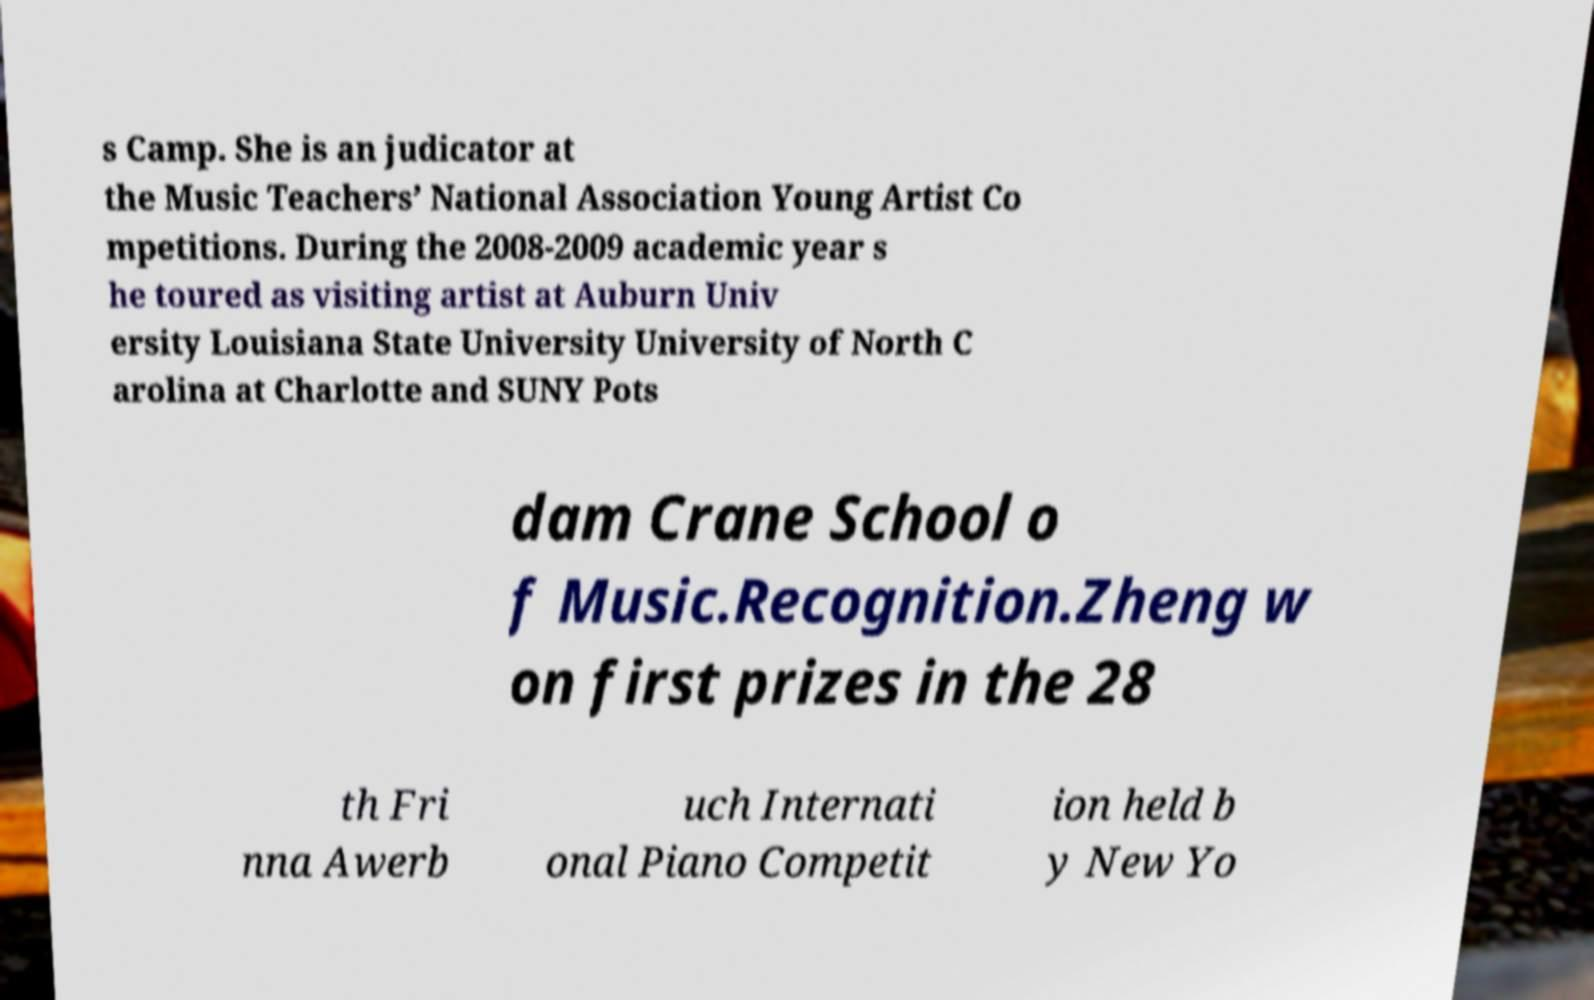There's text embedded in this image that I need extracted. Can you transcribe it verbatim? s Camp. She is an judicator at the Music Teachers’ National Association Young Artist Co mpetitions. During the 2008-2009 academic year s he toured as visiting artist at Auburn Univ ersity Louisiana State University University of North C arolina at Charlotte and SUNY Pots dam Crane School o f Music.Recognition.Zheng w on first prizes in the 28 th Fri nna Awerb uch Internati onal Piano Competit ion held b y New Yo 